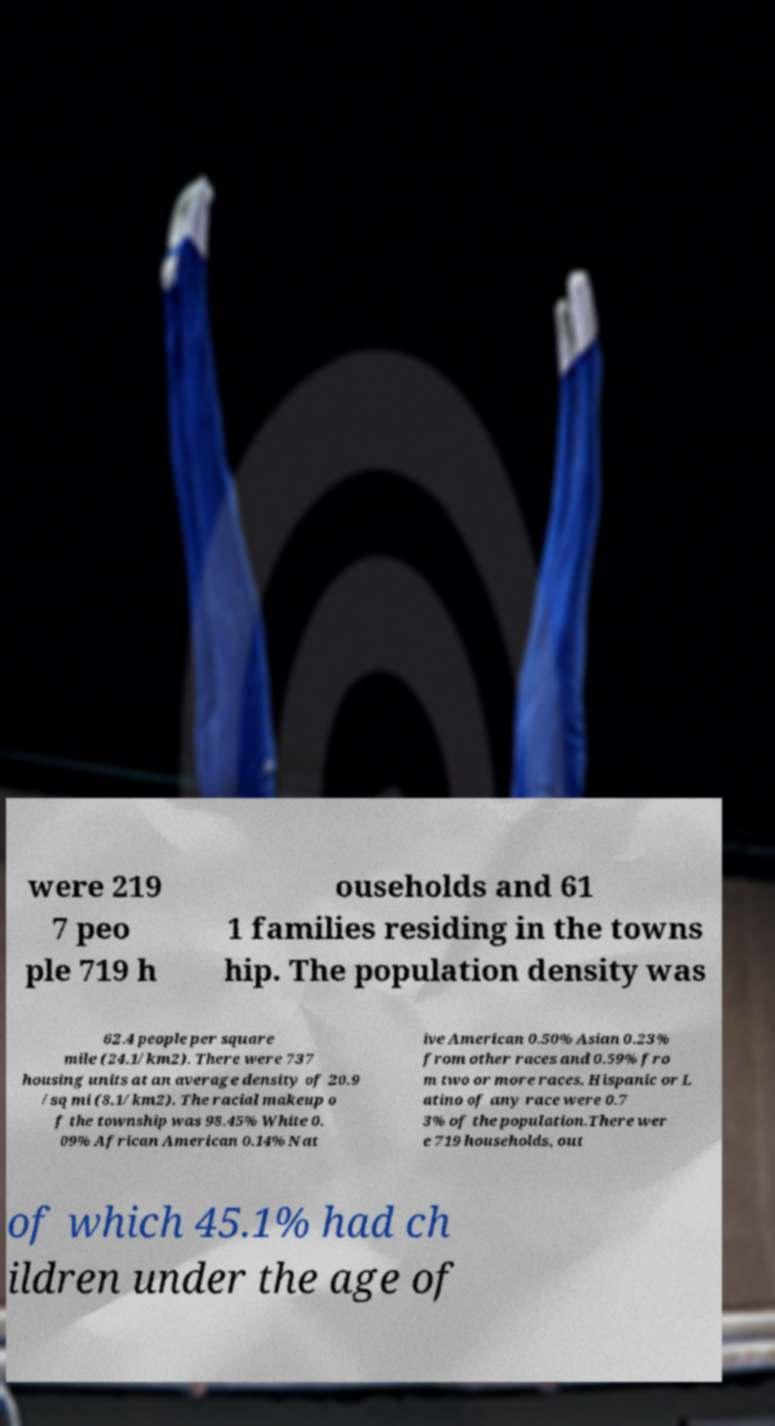Please identify and transcribe the text found in this image. were 219 7 peo ple 719 h ouseholds and 61 1 families residing in the towns hip. The population density was 62.4 people per square mile (24.1/km2). There were 737 housing units at an average density of 20.9 /sq mi (8.1/km2). The racial makeup o f the township was 98.45% White 0. 09% African American 0.14% Nat ive American 0.50% Asian 0.23% from other races and 0.59% fro m two or more races. Hispanic or L atino of any race were 0.7 3% of the population.There wer e 719 households, out of which 45.1% had ch ildren under the age of 